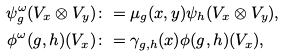Convert formula to latex. <formula><loc_0><loc_0><loc_500><loc_500>\psi _ { g } ^ { \omega } ( V _ { x } \otimes V _ { y } ) & \colon = \mu _ { g } ( x , y ) \psi _ { h } ( V _ { x } \otimes V _ { y } ) , \\ \phi ^ { \omega } ( g , h ) ( V _ { x } ) & \colon = \gamma _ { g , h } ( x ) \phi ( g , h ) ( V _ { x } ) ,</formula> 